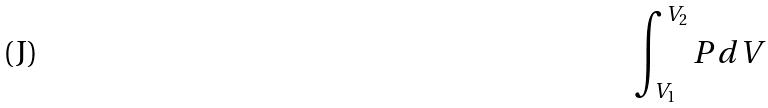Convert formula to latex. <formula><loc_0><loc_0><loc_500><loc_500>\int _ { V _ { 1 } } ^ { V _ { 2 } } P d V</formula> 